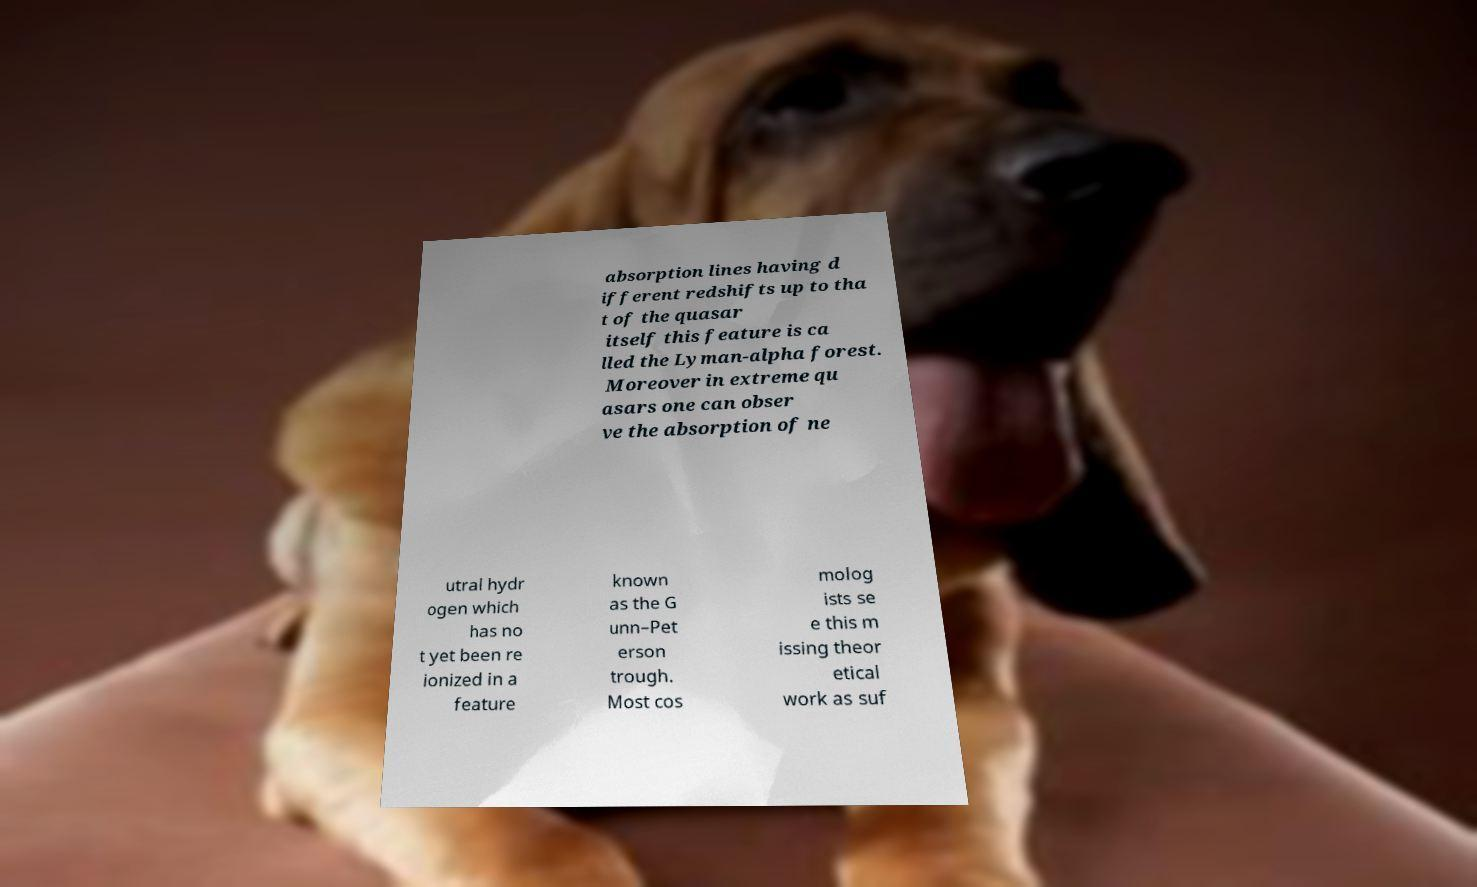Please read and relay the text visible in this image. What does it say? absorption lines having d ifferent redshifts up to tha t of the quasar itself this feature is ca lled the Lyman-alpha forest. Moreover in extreme qu asars one can obser ve the absorption of ne utral hydr ogen which has no t yet been re ionized in a feature known as the G unn–Pet erson trough. Most cos molog ists se e this m issing theor etical work as suf 